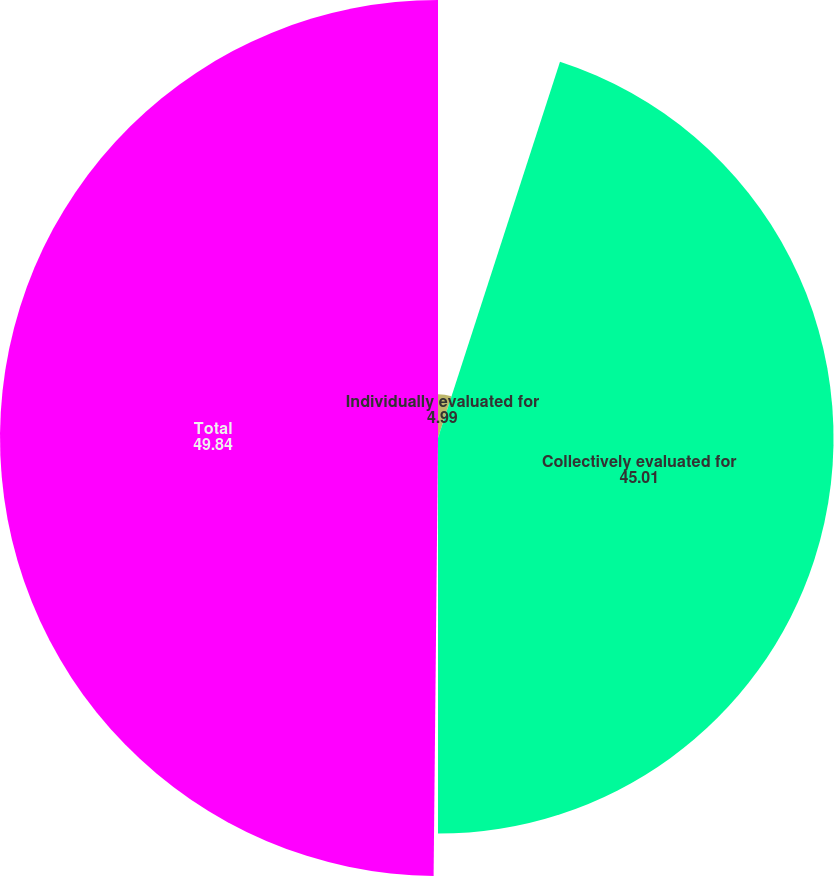Convert chart. <chart><loc_0><loc_0><loc_500><loc_500><pie_chart><fcel>Individually evaluated for<fcel>Collectively evaluated for<fcel>Purchased loans with evidence<fcel>Total<nl><fcel>4.99%<fcel>45.01%<fcel>0.16%<fcel>49.84%<nl></chart> 